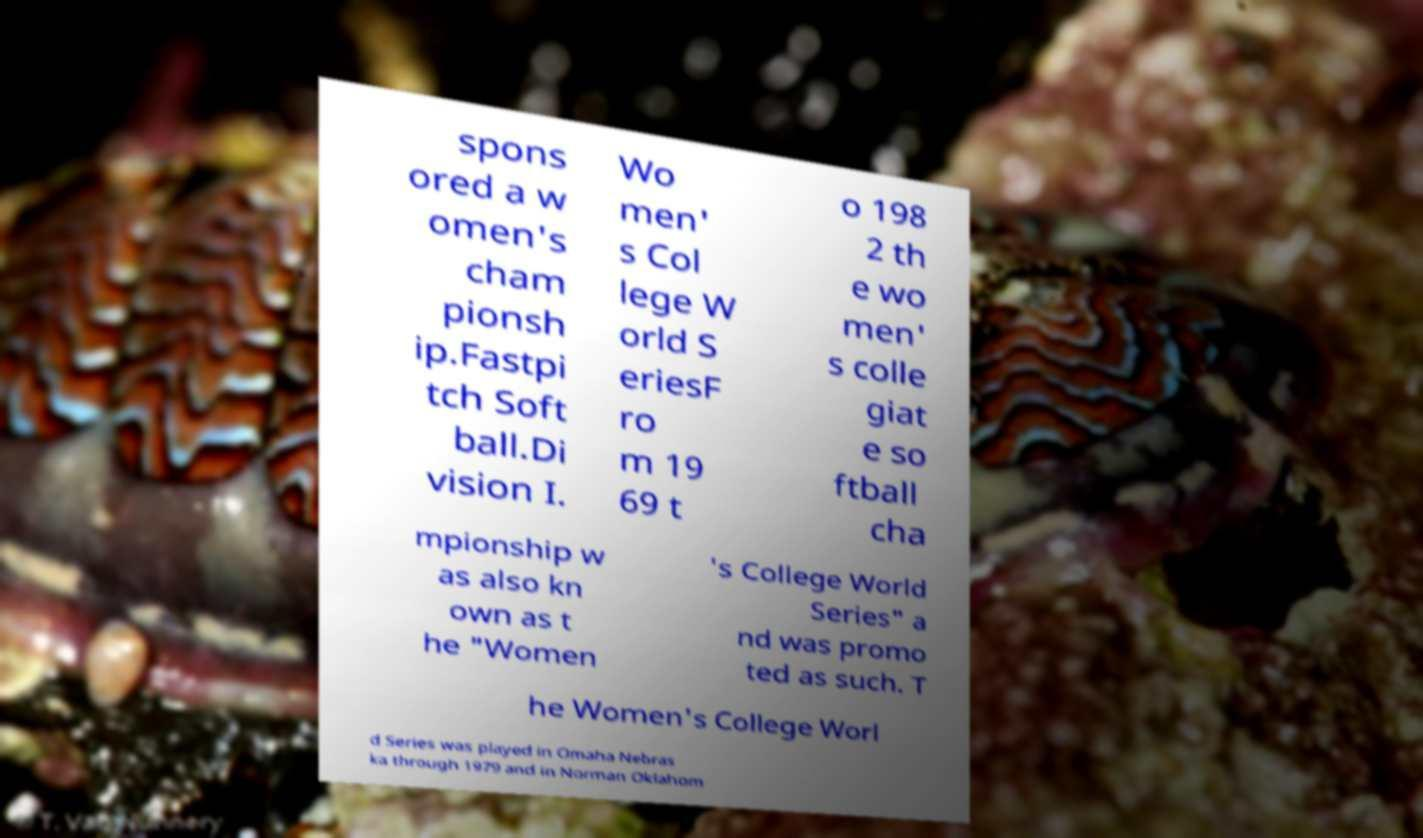Please read and relay the text visible in this image. What does it say? spons ored a w omen's cham pionsh ip.Fastpi tch Soft ball.Di vision I. Wo men' s Col lege W orld S eriesF ro m 19 69 t o 198 2 th e wo men' s colle giat e so ftball cha mpionship w as also kn own as t he "Women 's College World Series" a nd was promo ted as such. T he Women's College Worl d Series was played in Omaha Nebras ka through 1979 and in Norman Oklahom 